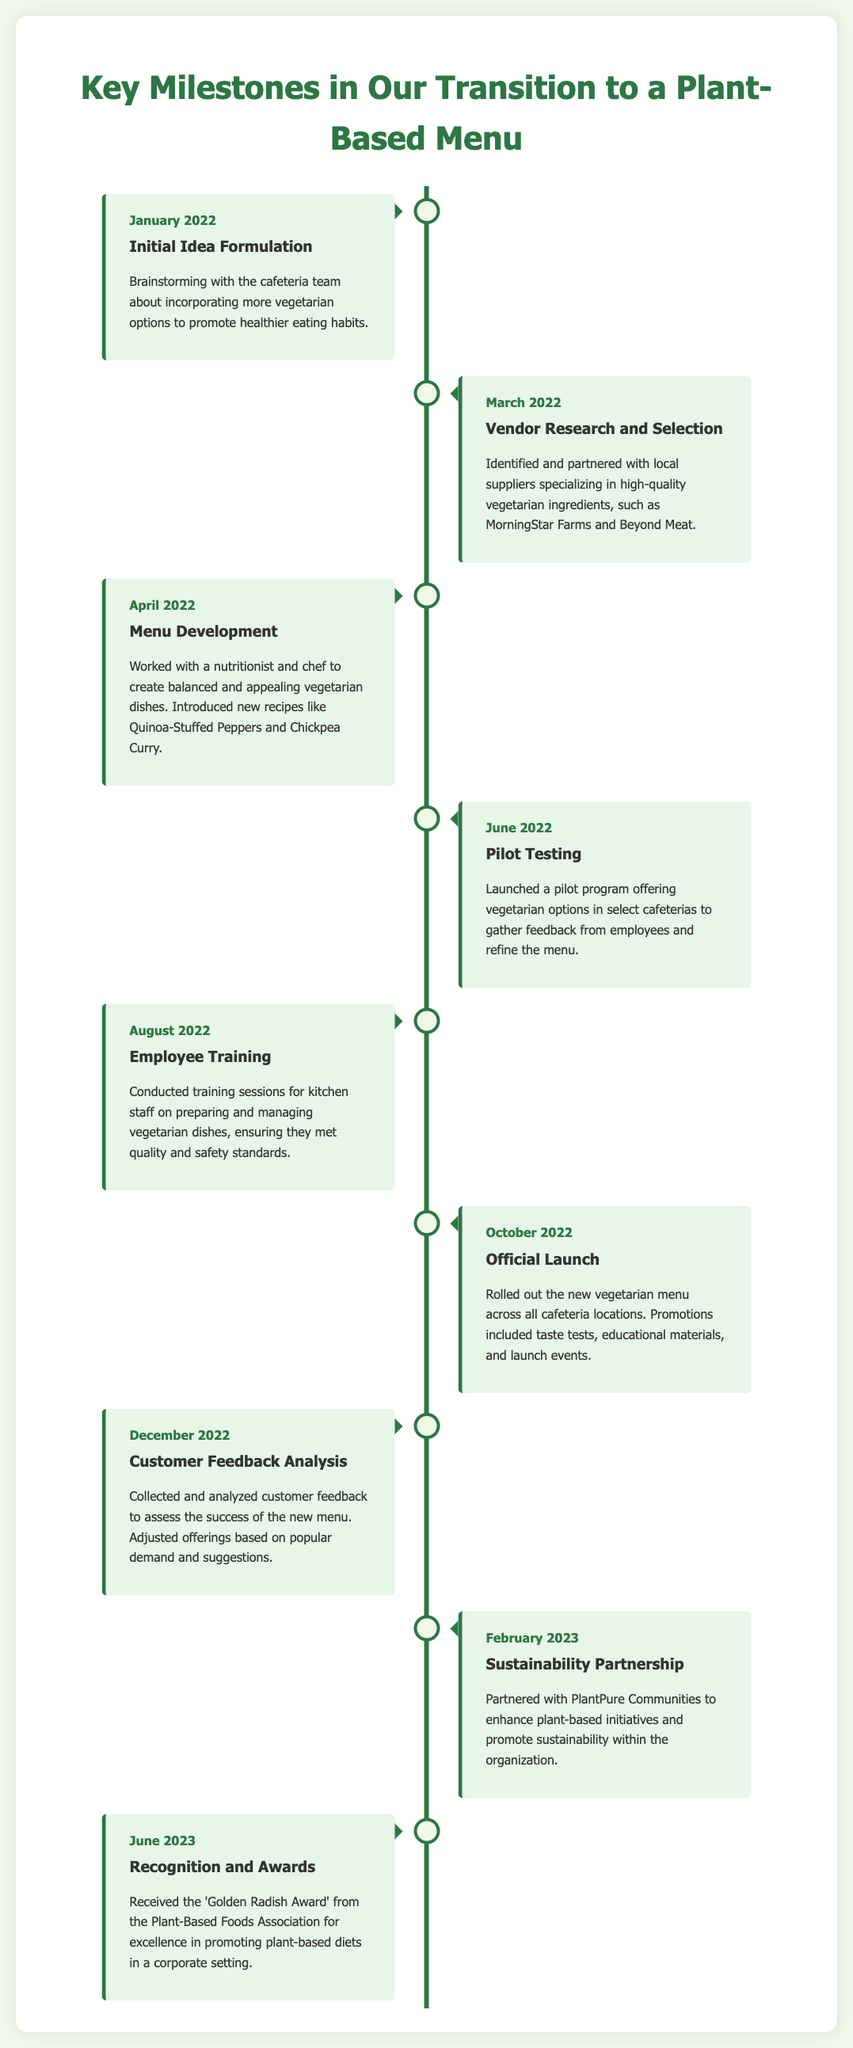what was the initial month of the transition? The document states that the initial idea formulation took place in January 2022.
Answer: January 2022 which company did we partner with for sustainability? According to the timeline, the partnership for sustainability was with PlantPure Communities.
Answer: PlantPure Communities what significant award did we receive in June 2023? The document mentions receiving the 'Golden Radish Award' for excellence in promoting plant-based diets.
Answer: Golden Radish Award how many months were there between the official launch and customer feedback analysis? The official launch occurred in October 2022, and customer feedback analysis was in December 2022, making it a two-month gap.
Answer: 2 months what month did we conduct employee training? The employee training was conducted in August 2022, as indicated in the timeline.
Answer: August 2022 which dishes were introduced during the menu development stage? The timeline specifies new recipes such as Quinoa-Stuffed Peppers and Chickpea Curry being developed.
Answer: Quinoa-Stuffed Peppers and Chickpea Curry what was the primary purpose of the pilot testing held in June 2022? The pilot testing aimed to gather feedback from employees on the vegetarian options offered in select cafeterias.
Answer: Gather feedback how many entries are in the timeline? There are eight key milestones recorded from January 2022 to June 2023.
Answer: Eight what type of program was launched in June 2022? The timeline indicates that a pilot program was launched to test vegetarian options in select cafeterias.
Answer: Pilot program 